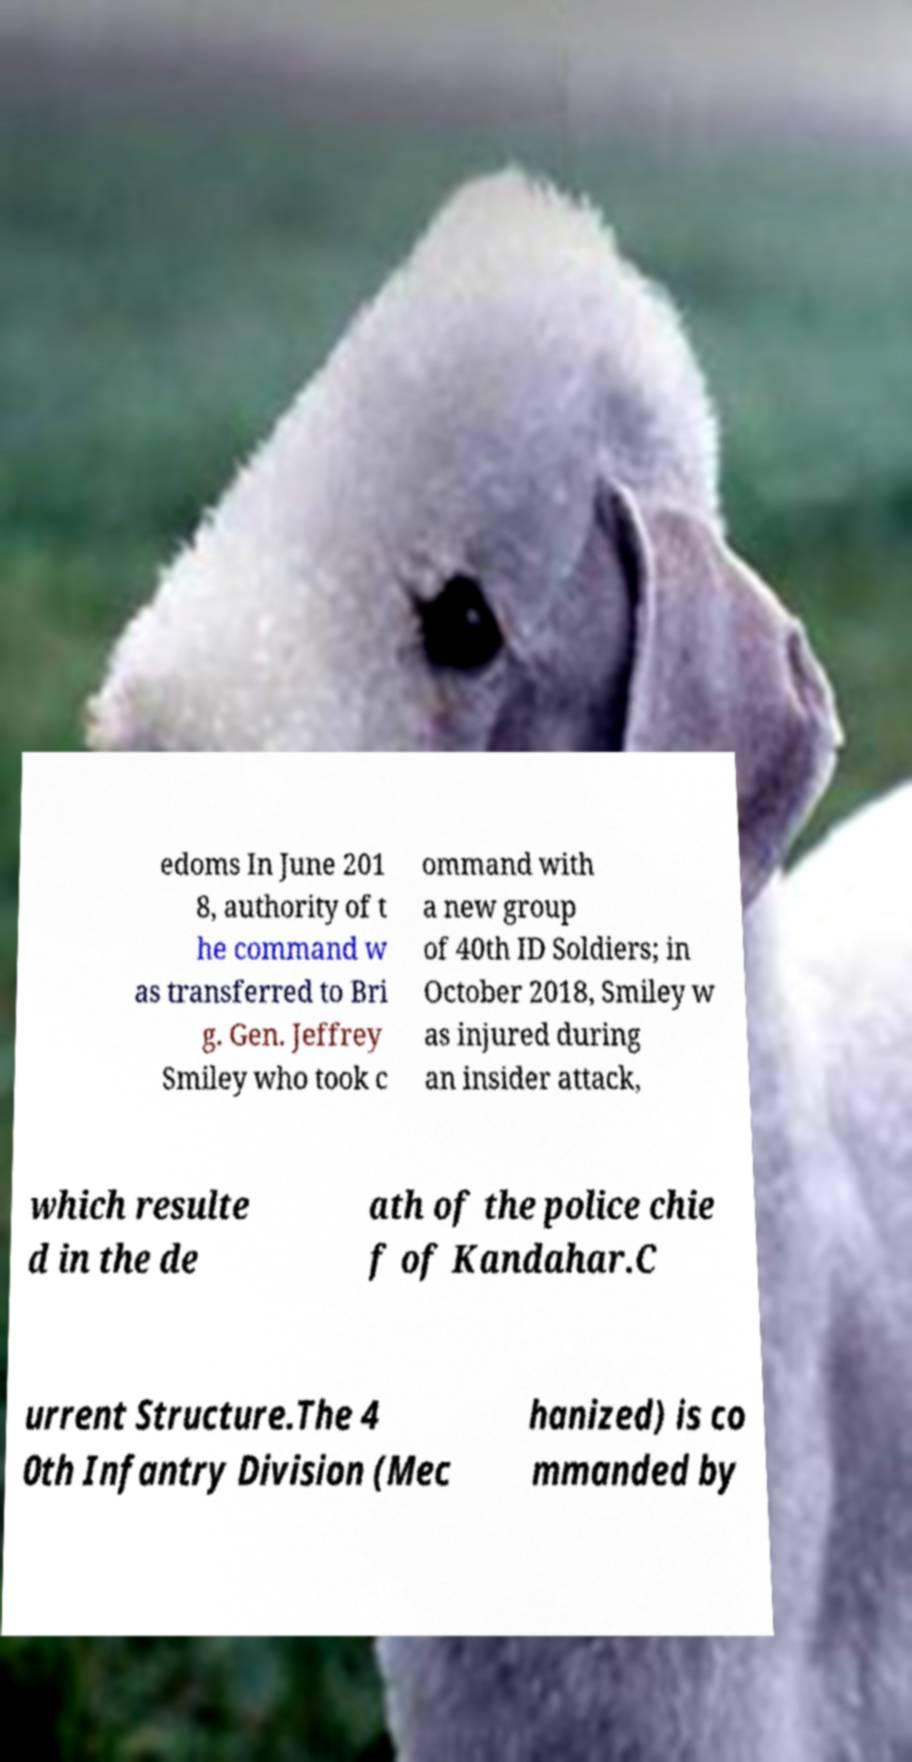Could you extract and type out the text from this image? edoms In June 201 8, authority of t he command w as transferred to Bri g. Gen. Jeffrey Smiley who took c ommand with a new group of 40th ID Soldiers; in October 2018, Smiley w as injured during an insider attack, which resulte d in the de ath of the police chie f of Kandahar.C urrent Structure.The 4 0th Infantry Division (Mec hanized) is co mmanded by 